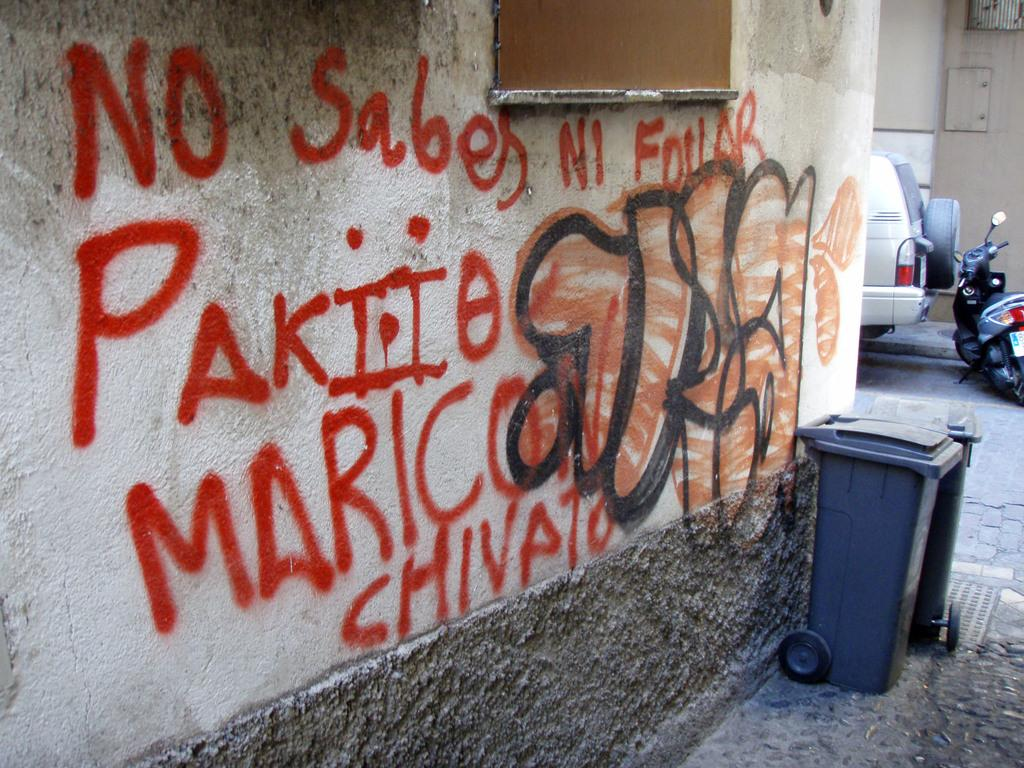<image>
Share a concise interpretation of the image provided. the word no is written in spray paint on a wall 